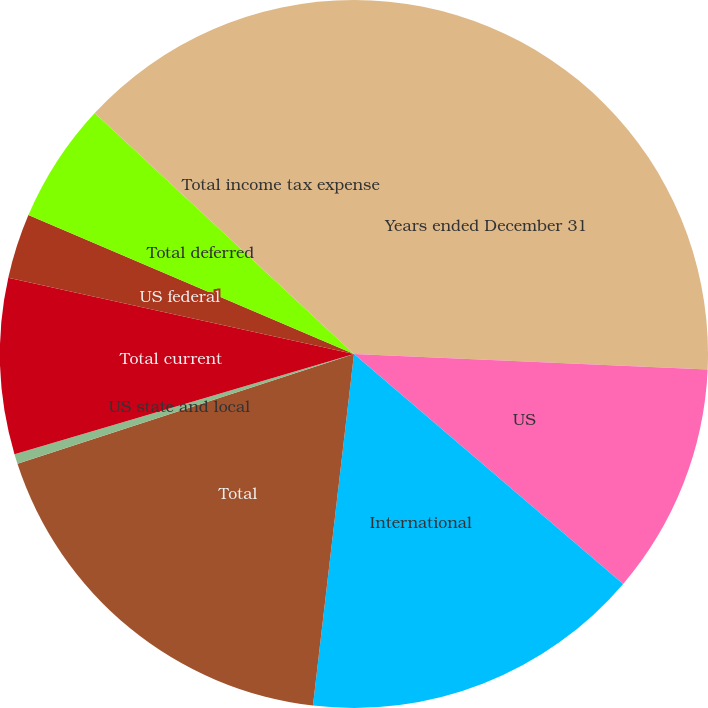Convert chart. <chart><loc_0><loc_0><loc_500><loc_500><pie_chart><fcel>Years ended December 31<fcel>US<fcel>International<fcel>Total<fcel>US state and local<fcel>Total current<fcel>US federal<fcel>Total deferred<fcel>Total income tax expense<nl><fcel>25.7%<fcel>10.55%<fcel>15.6%<fcel>18.13%<fcel>0.45%<fcel>8.02%<fcel>2.97%<fcel>5.5%<fcel>13.08%<nl></chart> 